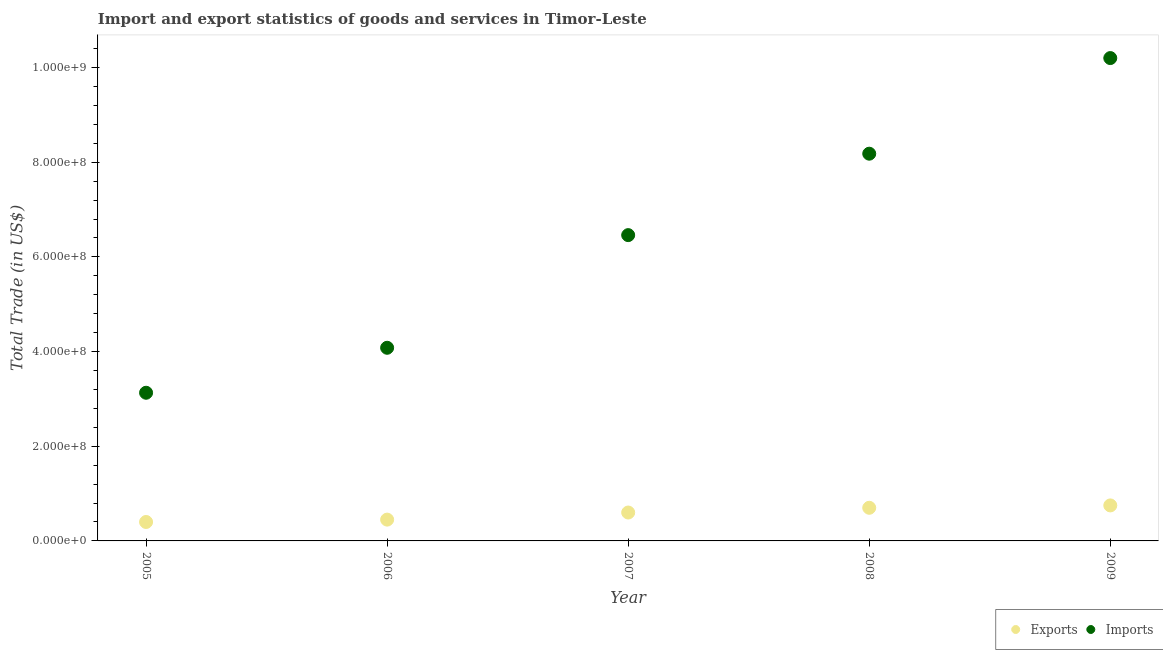What is the export of goods and services in 2008?
Provide a short and direct response. 7.00e+07. Across all years, what is the maximum export of goods and services?
Offer a very short reply. 7.50e+07. Across all years, what is the minimum imports of goods and services?
Provide a short and direct response. 3.13e+08. In which year was the export of goods and services maximum?
Your response must be concise. 2009. What is the total imports of goods and services in the graph?
Ensure brevity in your answer.  3.20e+09. What is the difference between the export of goods and services in 2005 and that in 2008?
Keep it short and to the point. -3.00e+07. What is the difference between the imports of goods and services in 2008 and the export of goods and services in 2005?
Your answer should be compact. 7.78e+08. What is the average export of goods and services per year?
Your response must be concise. 5.80e+07. In the year 2009, what is the difference between the imports of goods and services and export of goods and services?
Your answer should be compact. 9.45e+08. What is the ratio of the export of goods and services in 2007 to that in 2009?
Your response must be concise. 0.8. Is the imports of goods and services in 2007 less than that in 2008?
Make the answer very short. Yes. What is the difference between the highest and the second highest imports of goods and services?
Give a very brief answer. 2.02e+08. What is the difference between the highest and the lowest export of goods and services?
Keep it short and to the point. 3.50e+07. Is the sum of the imports of goods and services in 2008 and 2009 greater than the maximum export of goods and services across all years?
Ensure brevity in your answer.  Yes. Does the imports of goods and services monotonically increase over the years?
Ensure brevity in your answer.  Yes. Is the export of goods and services strictly greater than the imports of goods and services over the years?
Your answer should be very brief. No. Is the export of goods and services strictly less than the imports of goods and services over the years?
Provide a succinct answer. Yes. Does the graph contain any zero values?
Offer a very short reply. No. Does the graph contain grids?
Keep it short and to the point. No. Where does the legend appear in the graph?
Your answer should be very brief. Bottom right. What is the title of the graph?
Your answer should be very brief. Import and export statistics of goods and services in Timor-Leste. What is the label or title of the X-axis?
Provide a succinct answer. Year. What is the label or title of the Y-axis?
Offer a very short reply. Total Trade (in US$). What is the Total Trade (in US$) of Exports in 2005?
Your response must be concise. 4.00e+07. What is the Total Trade (in US$) in Imports in 2005?
Your answer should be very brief. 3.13e+08. What is the Total Trade (in US$) in Exports in 2006?
Give a very brief answer. 4.50e+07. What is the Total Trade (in US$) of Imports in 2006?
Provide a succinct answer. 4.08e+08. What is the Total Trade (in US$) of Exports in 2007?
Provide a succinct answer. 6.00e+07. What is the Total Trade (in US$) in Imports in 2007?
Give a very brief answer. 6.46e+08. What is the Total Trade (in US$) of Exports in 2008?
Your answer should be compact. 7.00e+07. What is the Total Trade (in US$) of Imports in 2008?
Provide a short and direct response. 8.18e+08. What is the Total Trade (in US$) of Exports in 2009?
Keep it short and to the point. 7.50e+07. What is the Total Trade (in US$) in Imports in 2009?
Keep it short and to the point. 1.02e+09. Across all years, what is the maximum Total Trade (in US$) of Exports?
Make the answer very short. 7.50e+07. Across all years, what is the maximum Total Trade (in US$) in Imports?
Your response must be concise. 1.02e+09. Across all years, what is the minimum Total Trade (in US$) in Exports?
Provide a succinct answer. 4.00e+07. Across all years, what is the minimum Total Trade (in US$) in Imports?
Your answer should be compact. 3.13e+08. What is the total Total Trade (in US$) of Exports in the graph?
Provide a short and direct response. 2.90e+08. What is the total Total Trade (in US$) in Imports in the graph?
Your response must be concise. 3.20e+09. What is the difference between the Total Trade (in US$) of Exports in 2005 and that in 2006?
Ensure brevity in your answer.  -5.00e+06. What is the difference between the Total Trade (in US$) in Imports in 2005 and that in 2006?
Your answer should be compact. -9.50e+07. What is the difference between the Total Trade (in US$) of Exports in 2005 and that in 2007?
Provide a short and direct response. -2.00e+07. What is the difference between the Total Trade (in US$) of Imports in 2005 and that in 2007?
Offer a very short reply. -3.33e+08. What is the difference between the Total Trade (in US$) of Exports in 2005 and that in 2008?
Offer a terse response. -3.00e+07. What is the difference between the Total Trade (in US$) in Imports in 2005 and that in 2008?
Provide a short and direct response. -5.05e+08. What is the difference between the Total Trade (in US$) in Exports in 2005 and that in 2009?
Ensure brevity in your answer.  -3.50e+07. What is the difference between the Total Trade (in US$) of Imports in 2005 and that in 2009?
Your answer should be compact. -7.07e+08. What is the difference between the Total Trade (in US$) of Exports in 2006 and that in 2007?
Ensure brevity in your answer.  -1.50e+07. What is the difference between the Total Trade (in US$) in Imports in 2006 and that in 2007?
Offer a terse response. -2.38e+08. What is the difference between the Total Trade (in US$) in Exports in 2006 and that in 2008?
Ensure brevity in your answer.  -2.50e+07. What is the difference between the Total Trade (in US$) in Imports in 2006 and that in 2008?
Keep it short and to the point. -4.10e+08. What is the difference between the Total Trade (in US$) of Exports in 2006 and that in 2009?
Offer a terse response. -3.00e+07. What is the difference between the Total Trade (in US$) in Imports in 2006 and that in 2009?
Ensure brevity in your answer.  -6.12e+08. What is the difference between the Total Trade (in US$) in Exports in 2007 and that in 2008?
Ensure brevity in your answer.  -1.00e+07. What is the difference between the Total Trade (in US$) of Imports in 2007 and that in 2008?
Your response must be concise. -1.72e+08. What is the difference between the Total Trade (in US$) of Exports in 2007 and that in 2009?
Provide a short and direct response. -1.50e+07. What is the difference between the Total Trade (in US$) of Imports in 2007 and that in 2009?
Your answer should be very brief. -3.74e+08. What is the difference between the Total Trade (in US$) of Exports in 2008 and that in 2009?
Your answer should be very brief. -5.00e+06. What is the difference between the Total Trade (in US$) in Imports in 2008 and that in 2009?
Provide a succinct answer. -2.02e+08. What is the difference between the Total Trade (in US$) of Exports in 2005 and the Total Trade (in US$) of Imports in 2006?
Your answer should be very brief. -3.68e+08. What is the difference between the Total Trade (in US$) in Exports in 2005 and the Total Trade (in US$) in Imports in 2007?
Keep it short and to the point. -6.06e+08. What is the difference between the Total Trade (in US$) in Exports in 2005 and the Total Trade (in US$) in Imports in 2008?
Make the answer very short. -7.78e+08. What is the difference between the Total Trade (in US$) in Exports in 2005 and the Total Trade (in US$) in Imports in 2009?
Give a very brief answer. -9.80e+08. What is the difference between the Total Trade (in US$) of Exports in 2006 and the Total Trade (in US$) of Imports in 2007?
Offer a very short reply. -6.01e+08. What is the difference between the Total Trade (in US$) of Exports in 2006 and the Total Trade (in US$) of Imports in 2008?
Provide a short and direct response. -7.73e+08. What is the difference between the Total Trade (in US$) in Exports in 2006 and the Total Trade (in US$) in Imports in 2009?
Keep it short and to the point. -9.75e+08. What is the difference between the Total Trade (in US$) of Exports in 2007 and the Total Trade (in US$) of Imports in 2008?
Make the answer very short. -7.58e+08. What is the difference between the Total Trade (in US$) in Exports in 2007 and the Total Trade (in US$) in Imports in 2009?
Ensure brevity in your answer.  -9.60e+08. What is the difference between the Total Trade (in US$) in Exports in 2008 and the Total Trade (in US$) in Imports in 2009?
Give a very brief answer. -9.50e+08. What is the average Total Trade (in US$) of Exports per year?
Make the answer very short. 5.80e+07. What is the average Total Trade (in US$) in Imports per year?
Your answer should be compact. 6.41e+08. In the year 2005, what is the difference between the Total Trade (in US$) of Exports and Total Trade (in US$) of Imports?
Offer a terse response. -2.73e+08. In the year 2006, what is the difference between the Total Trade (in US$) of Exports and Total Trade (in US$) of Imports?
Your answer should be very brief. -3.63e+08. In the year 2007, what is the difference between the Total Trade (in US$) of Exports and Total Trade (in US$) of Imports?
Provide a short and direct response. -5.86e+08. In the year 2008, what is the difference between the Total Trade (in US$) in Exports and Total Trade (in US$) in Imports?
Your response must be concise. -7.48e+08. In the year 2009, what is the difference between the Total Trade (in US$) in Exports and Total Trade (in US$) in Imports?
Offer a very short reply. -9.45e+08. What is the ratio of the Total Trade (in US$) in Exports in 2005 to that in 2006?
Ensure brevity in your answer.  0.89. What is the ratio of the Total Trade (in US$) in Imports in 2005 to that in 2006?
Your answer should be very brief. 0.77. What is the ratio of the Total Trade (in US$) of Exports in 2005 to that in 2007?
Offer a very short reply. 0.67. What is the ratio of the Total Trade (in US$) of Imports in 2005 to that in 2007?
Your answer should be compact. 0.48. What is the ratio of the Total Trade (in US$) of Imports in 2005 to that in 2008?
Provide a succinct answer. 0.38. What is the ratio of the Total Trade (in US$) of Exports in 2005 to that in 2009?
Offer a terse response. 0.53. What is the ratio of the Total Trade (in US$) in Imports in 2005 to that in 2009?
Your answer should be compact. 0.31. What is the ratio of the Total Trade (in US$) in Exports in 2006 to that in 2007?
Your answer should be very brief. 0.75. What is the ratio of the Total Trade (in US$) in Imports in 2006 to that in 2007?
Provide a short and direct response. 0.63. What is the ratio of the Total Trade (in US$) of Exports in 2006 to that in 2008?
Make the answer very short. 0.64. What is the ratio of the Total Trade (in US$) of Imports in 2006 to that in 2008?
Your answer should be compact. 0.5. What is the ratio of the Total Trade (in US$) of Exports in 2006 to that in 2009?
Give a very brief answer. 0.6. What is the ratio of the Total Trade (in US$) of Exports in 2007 to that in 2008?
Ensure brevity in your answer.  0.86. What is the ratio of the Total Trade (in US$) of Imports in 2007 to that in 2008?
Give a very brief answer. 0.79. What is the ratio of the Total Trade (in US$) in Imports in 2007 to that in 2009?
Offer a terse response. 0.63. What is the ratio of the Total Trade (in US$) of Exports in 2008 to that in 2009?
Give a very brief answer. 0.93. What is the ratio of the Total Trade (in US$) of Imports in 2008 to that in 2009?
Your answer should be very brief. 0.8. What is the difference between the highest and the second highest Total Trade (in US$) in Imports?
Offer a terse response. 2.02e+08. What is the difference between the highest and the lowest Total Trade (in US$) in Exports?
Provide a succinct answer. 3.50e+07. What is the difference between the highest and the lowest Total Trade (in US$) in Imports?
Offer a terse response. 7.07e+08. 